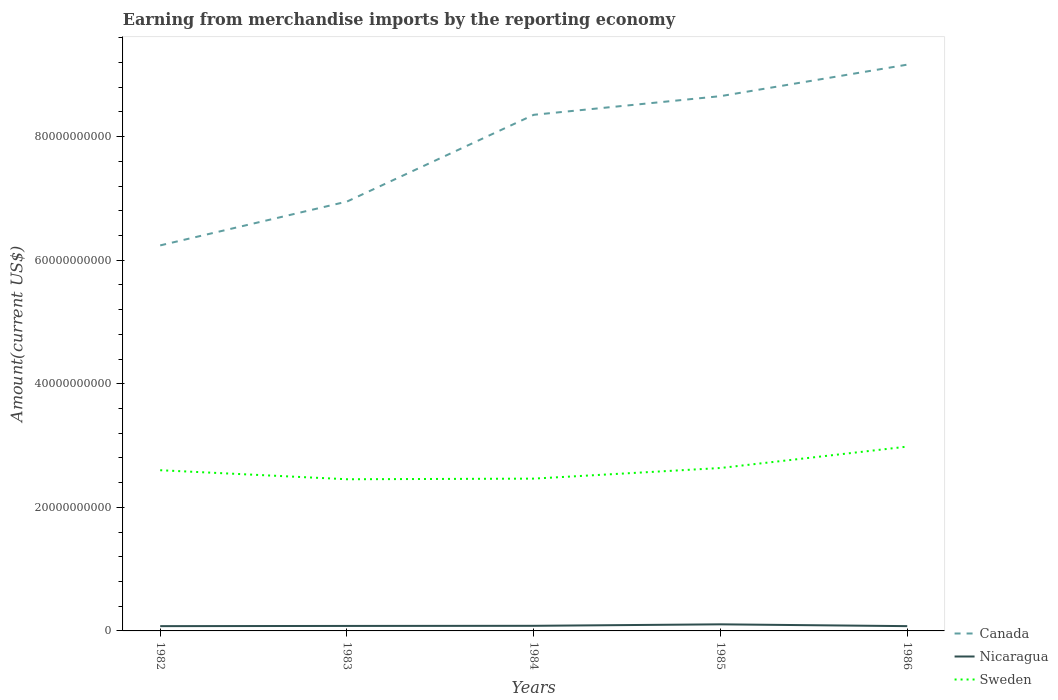How many different coloured lines are there?
Your answer should be compact. 3. Is the number of lines equal to the number of legend labels?
Provide a succinct answer. Yes. Across all years, what is the maximum amount earned from merchandise imports in Nicaragua?
Your answer should be compact. 7.74e+08. What is the total amount earned from merchandise imports in Nicaragua in the graph?
Keep it short and to the point. 3.18e+07. What is the difference between the highest and the second highest amount earned from merchandise imports in Sweden?
Provide a short and direct response. 5.28e+09. What is the difference between the highest and the lowest amount earned from merchandise imports in Canada?
Provide a short and direct response. 3. How many lines are there?
Make the answer very short. 3. What is the difference between two consecutive major ticks on the Y-axis?
Give a very brief answer. 2.00e+1. Does the graph contain any zero values?
Your answer should be very brief. No. Where does the legend appear in the graph?
Offer a very short reply. Bottom right. How are the legend labels stacked?
Your answer should be very brief. Vertical. What is the title of the graph?
Provide a succinct answer. Earning from merchandise imports by the reporting economy. What is the label or title of the X-axis?
Provide a short and direct response. Years. What is the label or title of the Y-axis?
Offer a very short reply. Amount(current US$). What is the Amount(current US$) in Canada in 1982?
Offer a terse response. 6.24e+1. What is the Amount(current US$) of Nicaragua in 1982?
Your response must be concise. 7.75e+08. What is the Amount(current US$) in Sweden in 1982?
Provide a succinct answer. 2.60e+1. What is the Amount(current US$) in Canada in 1983?
Make the answer very short. 6.95e+1. What is the Amount(current US$) in Nicaragua in 1983?
Make the answer very short. 8.06e+08. What is the Amount(current US$) in Sweden in 1983?
Keep it short and to the point. 2.45e+1. What is the Amount(current US$) of Canada in 1984?
Ensure brevity in your answer.  8.35e+1. What is the Amount(current US$) of Nicaragua in 1984?
Provide a short and direct response. 8.26e+08. What is the Amount(current US$) of Sweden in 1984?
Your answer should be very brief. 2.46e+1. What is the Amount(current US$) in Canada in 1985?
Your response must be concise. 8.65e+1. What is the Amount(current US$) of Nicaragua in 1985?
Keep it short and to the point. 1.07e+09. What is the Amount(current US$) in Sweden in 1985?
Your answer should be very brief. 2.64e+1. What is the Amount(current US$) in Canada in 1986?
Provide a succinct answer. 9.16e+1. What is the Amount(current US$) in Nicaragua in 1986?
Offer a terse response. 7.74e+08. What is the Amount(current US$) of Sweden in 1986?
Offer a very short reply. 2.98e+1. Across all years, what is the maximum Amount(current US$) in Canada?
Ensure brevity in your answer.  9.16e+1. Across all years, what is the maximum Amount(current US$) of Nicaragua?
Your response must be concise. 1.07e+09. Across all years, what is the maximum Amount(current US$) of Sweden?
Give a very brief answer. 2.98e+1. Across all years, what is the minimum Amount(current US$) in Canada?
Make the answer very short. 6.24e+1. Across all years, what is the minimum Amount(current US$) in Nicaragua?
Your answer should be compact. 7.74e+08. Across all years, what is the minimum Amount(current US$) of Sweden?
Offer a terse response. 2.45e+1. What is the total Amount(current US$) in Canada in the graph?
Provide a short and direct response. 3.94e+11. What is the total Amount(current US$) in Nicaragua in the graph?
Ensure brevity in your answer.  4.25e+09. What is the total Amount(current US$) in Sweden in the graph?
Offer a terse response. 1.31e+11. What is the difference between the Amount(current US$) of Canada in 1982 and that in 1983?
Provide a short and direct response. -7.09e+09. What is the difference between the Amount(current US$) in Nicaragua in 1982 and that in 1983?
Provide a succinct answer. -3.14e+07. What is the difference between the Amount(current US$) in Sweden in 1982 and that in 1983?
Provide a short and direct response. 1.46e+09. What is the difference between the Amount(current US$) of Canada in 1982 and that in 1984?
Ensure brevity in your answer.  -2.11e+1. What is the difference between the Amount(current US$) in Nicaragua in 1982 and that in 1984?
Make the answer very short. -5.10e+07. What is the difference between the Amount(current US$) of Sweden in 1982 and that in 1984?
Keep it short and to the point. 1.36e+09. What is the difference between the Amount(current US$) of Canada in 1982 and that in 1985?
Your answer should be very brief. -2.42e+1. What is the difference between the Amount(current US$) of Nicaragua in 1982 and that in 1985?
Keep it short and to the point. -2.92e+08. What is the difference between the Amount(current US$) in Sweden in 1982 and that in 1985?
Offer a very short reply. -3.59e+08. What is the difference between the Amount(current US$) of Canada in 1982 and that in 1986?
Your answer should be compact. -2.93e+1. What is the difference between the Amount(current US$) of Nicaragua in 1982 and that in 1986?
Your answer should be very brief. 3.82e+05. What is the difference between the Amount(current US$) of Sweden in 1982 and that in 1986?
Your answer should be compact. -3.82e+09. What is the difference between the Amount(current US$) in Canada in 1983 and that in 1984?
Your answer should be very brief. -1.40e+1. What is the difference between the Amount(current US$) in Nicaragua in 1983 and that in 1984?
Offer a very short reply. -1.96e+07. What is the difference between the Amount(current US$) of Sweden in 1983 and that in 1984?
Your answer should be very brief. -9.96e+07. What is the difference between the Amount(current US$) in Canada in 1983 and that in 1985?
Provide a short and direct response. -1.71e+1. What is the difference between the Amount(current US$) in Nicaragua in 1983 and that in 1985?
Keep it short and to the point. -2.60e+08. What is the difference between the Amount(current US$) of Sweden in 1983 and that in 1985?
Provide a short and direct response. -1.82e+09. What is the difference between the Amount(current US$) in Canada in 1983 and that in 1986?
Your answer should be compact. -2.22e+1. What is the difference between the Amount(current US$) in Nicaragua in 1983 and that in 1986?
Make the answer very short. 3.18e+07. What is the difference between the Amount(current US$) of Sweden in 1983 and that in 1986?
Provide a succinct answer. -5.28e+09. What is the difference between the Amount(current US$) in Canada in 1984 and that in 1985?
Your response must be concise. -3.02e+09. What is the difference between the Amount(current US$) of Nicaragua in 1984 and that in 1985?
Provide a short and direct response. -2.41e+08. What is the difference between the Amount(current US$) of Sweden in 1984 and that in 1985?
Your answer should be compact. -1.72e+09. What is the difference between the Amount(current US$) in Canada in 1984 and that in 1986?
Ensure brevity in your answer.  -8.12e+09. What is the difference between the Amount(current US$) in Nicaragua in 1984 and that in 1986?
Give a very brief answer. 5.14e+07. What is the difference between the Amount(current US$) in Sweden in 1984 and that in 1986?
Your response must be concise. -5.18e+09. What is the difference between the Amount(current US$) in Canada in 1985 and that in 1986?
Offer a terse response. -5.10e+09. What is the difference between the Amount(current US$) in Nicaragua in 1985 and that in 1986?
Your answer should be compact. 2.92e+08. What is the difference between the Amount(current US$) in Sweden in 1985 and that in 1986?
Your answer should be compact. -3.46e+09. What is the difference between the Amount(current US$) in Canada in 1982 and the Amount(current US$) in Nicaragua in 1983?
Your response must be concise. 6.16e+1. What is the difference between the Amount(current US$) in Canada in 1982 and the Amount(current US$) in Sweden in 1983?
Make the answer very short. 3.78e+1. What is the difference between the Amount(current US$) in Nicaragua in 1982 and the Amount(current US$) in Sweden in 1983?
Your response must be concise. -2.38e+1. What is the difference between the Amount(current US$) in Canada in 1982 and the Amount(current US$) in Nicaragua in 1984?
Offer a terse response. 6.16e+1. What is the difference between the Amount(current US$) of Canada in 1982 and the Amount(current US$) of Sweden in 1984?
Provide a succinct answer. 3.77e+1. What is the difference between the Amount(current US$) of Nicaragua in 1982 and the Amount(current US$) of Sweden in 1984?
Your response must be concise. -2.39e+1. What is the difference between the Amount(current US$) in Canada in 1982 and the Amount(current US$) in Nicaragua in 1985?
Your answer should be very brief. 6.13e+1. What is the difference between the Amount(current US$) in Canada in 1982 and the Amount(current US$) in Sweden in 1985?
Ensure brevity in your answer.  3.60e+1. What is the difference between the Amount(current US$) in Nicaragua in 1982 and the Amount(current US$) in Sweden in 1985?
Ensure brevity in your answer.  -2.56e+1. What is the difference between the Amount(current US$) in Canada in 1982 and the Amount(current US$) in Nicaragua in 1986?
Make the answer very short. 6.16e+1. What is the difference between the Amount(current US$) of Canada in 1982 and the Amount(current US$) of Sweden in 1986?
Offer a terse response. 3.26e+1. What is the difference between the Amount(current US$) in Nicaragua in 1982 and the Amount(current US$) in Sweden in 1986?
Make the answer very short. -2.91e+1. What is the difference between the Amount(current US$) in Canada in 1983 and the Amount(current US$) in Nicaragua in 1984?
Provide a succinct answer. 6.87e+1. What is the difference between the Amount(current US$) in Canada in 1983 and the Amount(current US$) in Sweden in 1984?
Offer a very short reply. 4.48e+1. What is the difference between the Amount(current US$) of Nicaragua in 1983 and the Amount(current US$) of Sweden in 1984?
Offer a very short reply. -2.38e+1. What is the difference between the Amount(current US$) in Canada in 1983 and the Amount(current US$) in Nicaragua in 1985?
Ensure brevity in your answer.  6.84e+1. What is the difference between the Amount(current US$) in Canada in 1983 and the Amount(current US$) in Sweden in 1985?
Ensure brevity in your answer.  4.31e+1. What is the difference between the Amount(current US$) of Nicaragua in 1983 and the Amount(current US$) of Sweden in 1985?
Ensure brevity in your answer.  -2.56e+1. What is the difference between the Amount(current US$) of Canada in 1983 and the Amount(current US$) of Nicaragua in 1986?
Offer a terse response. 6.87e+1. What is the difference between the Amount(current US$) in Canada in 1983 and the Amount(current US$) in Sweden in 1986?
Your answer should be very brief. 3.97e+1. What is the difference between the Amount(current US$) in Nicaragua in 1983 and the Amount(current US$) in Sweden in 1986?
Your answer should be very brief. -2.90e+1. What is the difference between the Amount(current US$) in Canada in 1984 and the Amount(current US$) in Nicaragua in 1985?
Offer a terse response. 8.25e+1. What is the difference between the Amount(current US$) in Canada in 1984 and the Amount(current US$) in Sweden in 1985?
Keep it short and to the point. 5.72e+1. What is the difference between the Amount(current US$) in Nicaragua in 1984 and the Amount(current US$) in Sweden in 1985?
Make the answer very short. -2.55e+1. What is the difference between the Amount(current US$) of Canada in 1984 and the Amount(current US$) of Nicaragua in 1986?
Ensure brevity in your answer.  8.27e+1. What is the difference between the Amount(current US$) of Canada in 1984 and the Amount(current US$) of Sweden in 1986?
Ensure brevity in your answer.  5.37e+1. What is the difference between the Amount(current US$) in Nicaragua in 1984 and the Amount(current US$) in Sweden in 1986?
Provide a short and direct response. -2.90e+1. What is the difference between the Amount(current US$) of Canada in 1985 and the Amount(current US$) of Nicaragua in 1986?
Offer a very short reply. 8.58e+1. What is the difference between the Amount(current US$) of Canada in 1985 and the Amount(current US$) of Sweden in 1986?
Keep it short and to the point. 5.67e+1. What is the difference between the Amount(current US$) in Nicaragua in 1985 and the Amount(current US$) in Sweden in 1986?
Give a very brief answer. -2.88e+1. What is the average Amount(current US$) in Canada per year?
Provide a succinct answer. 7.87e+1. What is the average Amount(current US$) of Nicaragua per year?
Provide a short and direct response. 8.50e+08. What is the average Amount(current US$) of Sweden per year?
Offer a terse response. 2.63e+1. In the year 1982, what is the difference between the Amount(current US$) in Canada and Amount(current US$) in Nicaragua?
Offer a terse response. 6.16e+1. In the year 1982, what is the difference between the Amount(current US$) of Canada and Amount(current US$) of Sweden?
Offer a terse response. 3.64e+1. In the year 1982, what is the difference between the Amount(current US$) of Nicaragua and Amount(current US$) of Sweden?
Make the answer very short. -2.52e+1. In the year 1983, what is the difference between the Amount(current US$) in Canada and Amount(current US$) in Nicaragua?
Provide a short and direct response. 6.87e+1. In the year 1983, what is the difference between the Amount(current US$) of Canada and Amount(current US$) of Sweden?
Ensure brevity in your answer.  4.49e+1. In the year 1983, what is the difference between the Amount(current US$) in Nicaragua and Amount(current US$) in Sweden?
Provide a succinct answer. -2.37e+1. In the year 1984, what is the difference between the Amount(current US$) in Canada and Amount(current US$) in Nicaragua?
Provide a short and direct response. 8.27e+1. In the year 1984, what is the difference between the Amount(current US$) of Canada and Amount(current US$) of Sweden?
Provide a succinct answer. 5.89e+1. In the year 1984, what is the difference between the Amount(current US$) of Nicaragua and Amount(current US$) of Sweden?
Your answer should be compact. -2.38e+1. In the year 1985, what is the difference between the Amount(current US$) in Canada and Amount(current US$) in Nicaragua?
Make the answer very short. 8.55e+1. In the year 1985, what is the difference between the Amount(current US$) in Canada and Amount(current US$) in Sweden?
Give a very brief answer. 6.02e+1. In the year 1985, what is the difference between the Amount(current US$) of Nicaragua and Amount(current US$) of Sweden?
Your answer should be very brief. -2.53e+1. In the year 1986, what is the difference between the Amount(current US$) of Canada and Amount(current US$) of Nicaragua?
Offer a very short reply. 9.09e+1. In the year 1986, what is the difference between the Amount(current US$) of Canada and Amount(current US$) of Sweden?
Your answer should be compact. 6.18e+1. In the year 1986, what is the difference between the Amount(current US$) of Nicaragua and Amount(current US$) of Sweden?
Provide a succinct answer. -2.91e+1. What is the ratio of the Amount(current US$) of Canada in 1982 to that in 1983?
Provide a succinct answer. 0.9. What is the ratio of the Amount(current US$) of Nicaragua in 1982 to that in 1983?
Provide a succinct answer. 0.96. What is the ratio of the Amount(current US$) of Sweden in 1982 to that in 1983?
Your answer should be very brief. 1.06. What is the ratio of the Amount(current US$) of Canada in 1982 to that in 1984?
Provide a short and direct response. 0.75. What is the ratio of the Amount(current US$) in Nicaragua in 1982 to that in 1984?
Your response must be concise. 0.94. What is the ratio of the Amount(current US$) in Sweden in 1982 to that in 1984?
Provide a succinct answer. 1.06. What is the ratio of the Amount(current US$) of Canada in 1982 to that in 1985?
Offer a very short reply. 0.72. What is the ratio of the Amount(current US$) of Nicaragua in 1982 to that in 1985?
Offer a terse response. 0.73. What is the ratio of the Amount(current US$) in Sweden in 1982 to that in 1985?
Give a very brief answer. 0.99. What is the ratio of the Amount(current US$) of Canada in 1982 to that in 1986?
Make the answer very short. 0.68. What is the ratio of the Amount(current US$) in Sweden in 1982 to that in 1986?
Provide a short and direct response. 0.87. What is the ratio of the Amount(current US$) of Canada in 1983 to that in 1984?
Your response must be concise. 0.83. What is the ratio of the Amount(current US$) in Nicaragua in 1983 to that in 1984?
Provide a succinct answer. 0.98. What is the ratio of the Amount(current US$) of Canada in 1983 to that in 1985?
Give a very brief answer. 0.8. What is the ratio of the Amount(current US$) in Nicaragua in 1983 to that in 1985?
Keep it short and to the point. 0.76. What is the ratio of the Amount(current US$) of Canada in 1983 to that in 1986?
Provide a short and direct response. 0.76. What is the ratio of the Amount(current US$) of Nicaragua in 1983 to that in 1986?
Your answer should be very brief. 1.04. What is the ratio of the Amount(current US$) in Sweden in 1983 to that in 1986?
Your response must be concise. 0.82. What is the ratio of the Amount(current US$) of Canada in 1984 to that in 1985?
Make the answer very short. 0.97. What is the ratio of the Amount(current US$) in Nicaragua in 1984 to that in 1985?
Your answer should be very brief. 0.77. What is the ratio of the Amount(current US$) in Sweden in 1984 to that in 1985?
Your answer should be compact. 0.93. What is the ratio of the Amount(current US$) in Canada in 1984 to that in 1986?
Make the answer very short. 0.91. What is the ratio of the Amount(current US$) of Nicaragua in 1984 to that in 1986?
Offer a very short reply. 1.07. What is the ratio of the Amount(current US$) in Sweden in 1984 to that in 1986?
Provide a short and direct response. 0.83. What is the ratio of the Amount(current US$) of Nicaragua in 1985 to that in 1986?
Your answer should be compact. 1.38. What is the ratio of the Amount(current US$) of Sweden in 1985 to that in 1986?
Ensure brevity in your answer.  0.88. What is the difference between the highest and the second highest Amount(current US$) in Canada?
Provide a short and direct response. 5.10e+09. What is the difference between the highest and the second highest Amount(current US$) of Nicaragua?
Your answer should be very brief. 2.41e+08. What is the difference between the highest and the second highest Amount(current US$) in Sweden?
Your answer should be compact. 3.46e+09. What is the difference between the highest and the lowest Amount(current US$) in Canada?
Give a very brief answer. 2.93e+1. What is the difference between the highest and the lowest Amount(current US$) of Nicaragua?
Provide a succinct answer. 2.92e+08. What is the difference between the highest and the lowest Amount(current US$) in Sweden?
Provide a short and direct response. 5.28e+09. 